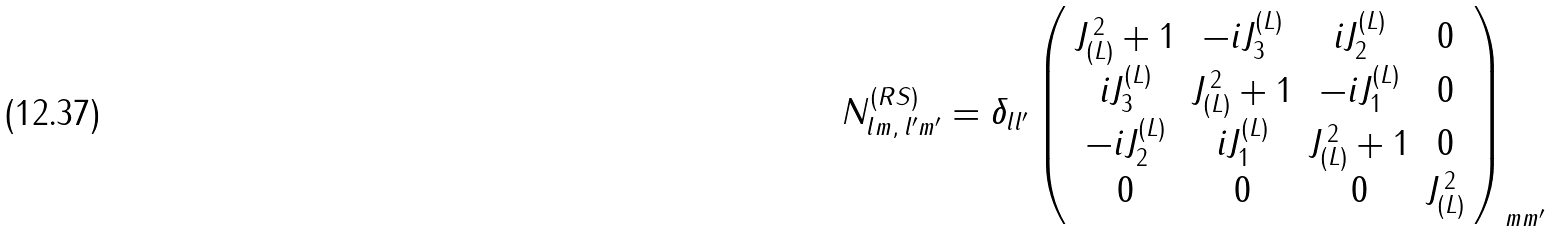<formula> <loc_0><loc_0><loc_500><loc_500>N ^ { ( R S ) } _ { l m , \, l ^ { \prime } m ^ { \prime } } = \delta _ { l l ^ { \prime } } \left ( \begin{array} { c c c c } J _ { ( L ) } ^ { \, 2 } + 1 & - i J ^ { ( L ) } _ { 3 } & i J ^ { ( L ) } _ { 2 } & 0 \\ i J ^ { ( L ) } _ { 3 } & J _ { ( L ) } ^ { \, 2 } + 1 & - i J ^ { ( L ) } _ { 1 } & 0 \\ - i J ^ { ( L ) } _ { 2 } & i J ^ { ( L ) } _ { 1 } & J _ { ( L ) } ^ { \, 2 } + 1 & 0 \\ 0 & 0 & 0 & J _ { ( L ) } ^ { \, 2 } \end{array} \right ) _ { m m ^ { \prime } }</formula> 